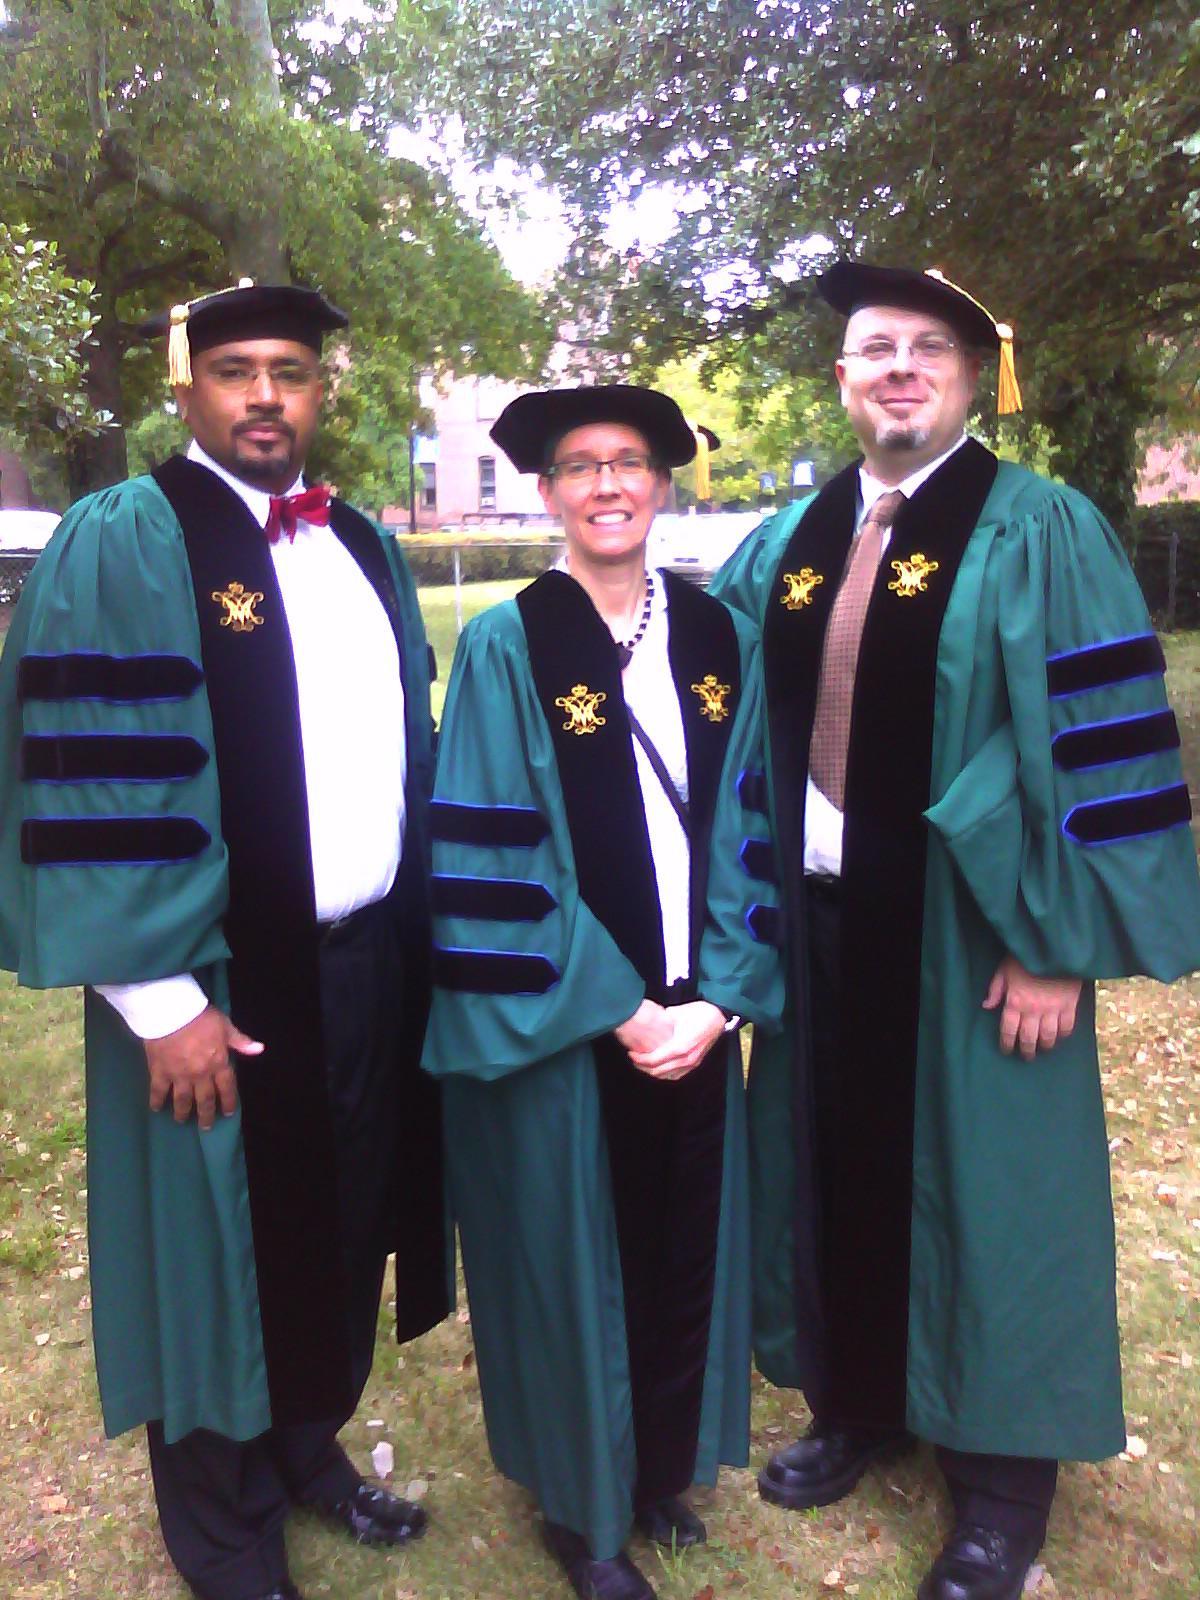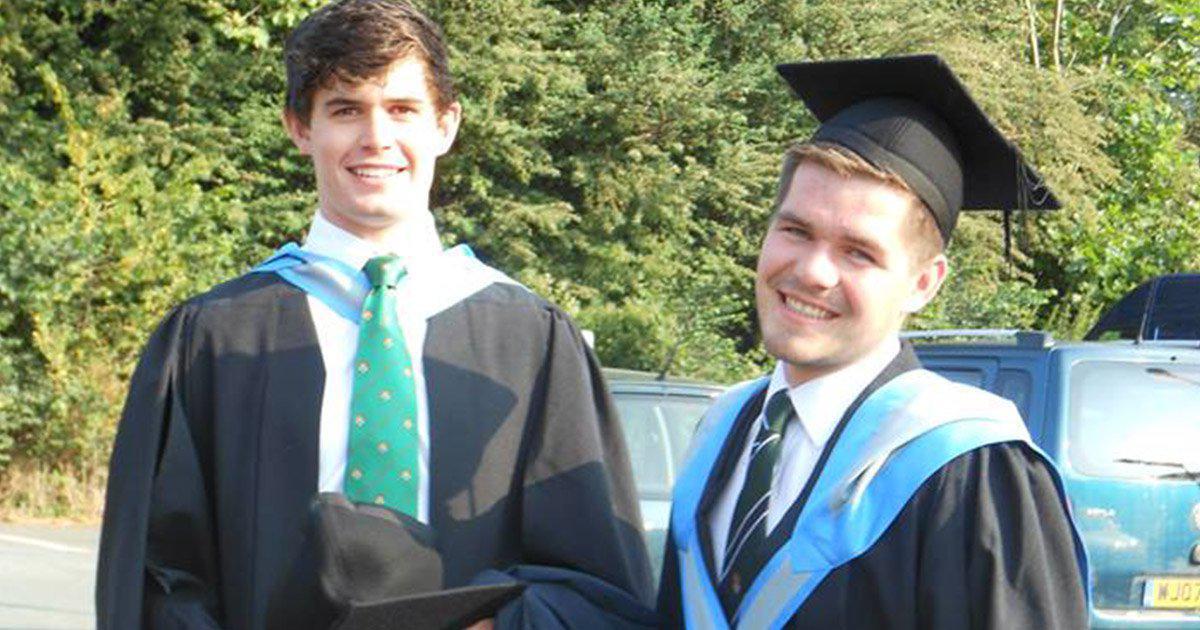The first image is the image on the left, the second image is the image on the right. Given the left and right images, does the statement "There are two men with their shirts visible underneath there graduation gowns." hold true? Answer yes or no. Yes. The first image is the image on the left, the second image is the image on the right. Analyze the images presented: Is the assertion "The image on the left does not contain more than two people." valid? Answer yes or no. No. 